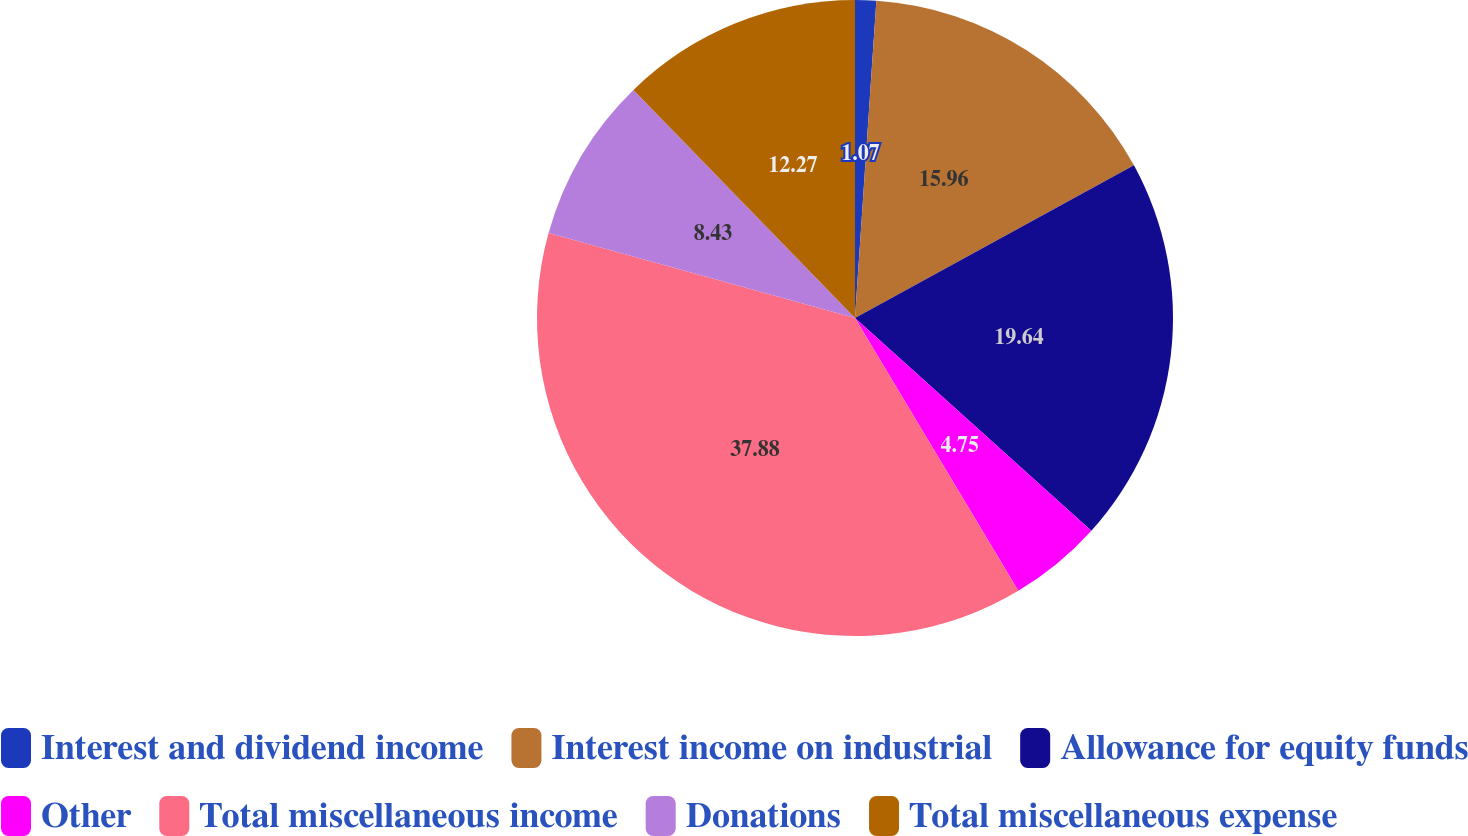Convert chart. <chart><loc_0><loc_0><loc_500><loc_500><pie_chart><fcel>Interest and dividend income<fcel>Interest income on industrial<fcel>Allowance for equity funds<fcel>Other<fcel>Total miscellaneous income<fcel>Donations<fcel>Total miscellaneous expense<nl><fcel>1.07%<fcel>15.96%<fcel>19.64%<fcel>4.75%<fcel>37.89%<fcel>8.43%<fcel>12.27%<nl></chart> 